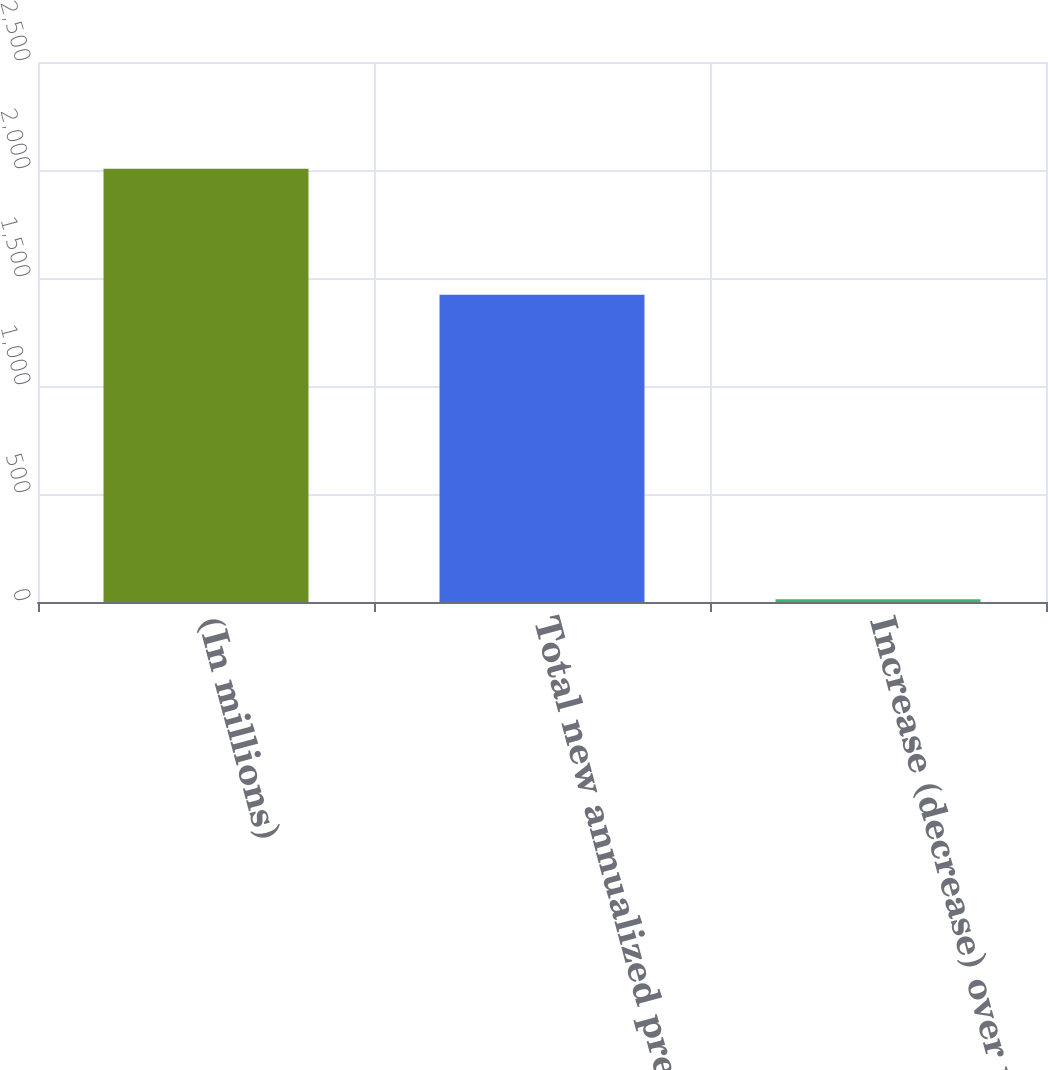<chart> <loc_0><loc_0><loc_500><loc_500><bar_chart><fcel>(In millions)<fcel>Total new annualized premium<fcel>Increase (decrease) over prior<nl><fcel>2006<fcel>1423<fcel>13.1<nl></chart> 